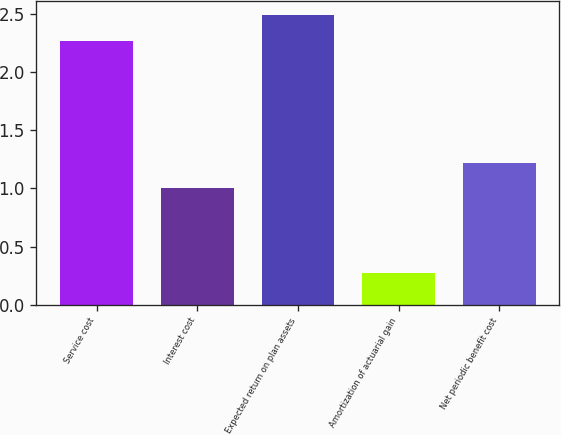Convert chart. <chart><loc_0><loc_0><loc_500><loc_500><bar_chart><fcel>Service cost<fcel>Interest cost<fcel>Expected return on plan assets<fcel>Amortization of actuarial gain<fcel>Net periodic benefit cost<nl><fcel>2.27<fcel>1<fcel>2.49<fcel>0.27<fcel>1.22<nl></chart> 